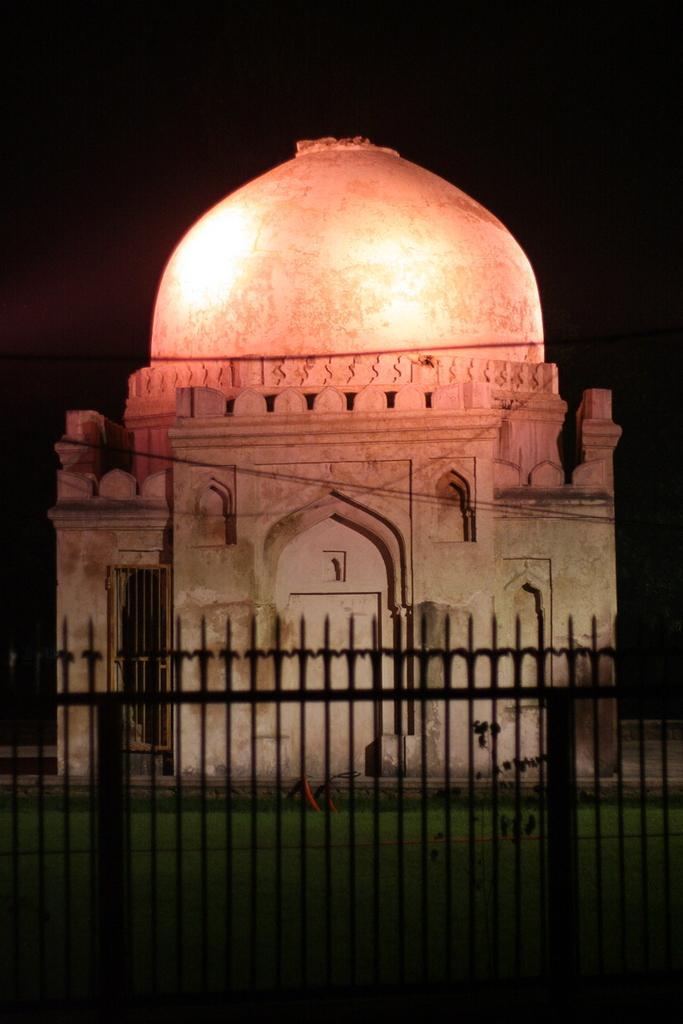Please provide a concise description of this image. In this image I can see the railing and the building. I can see the black background. 